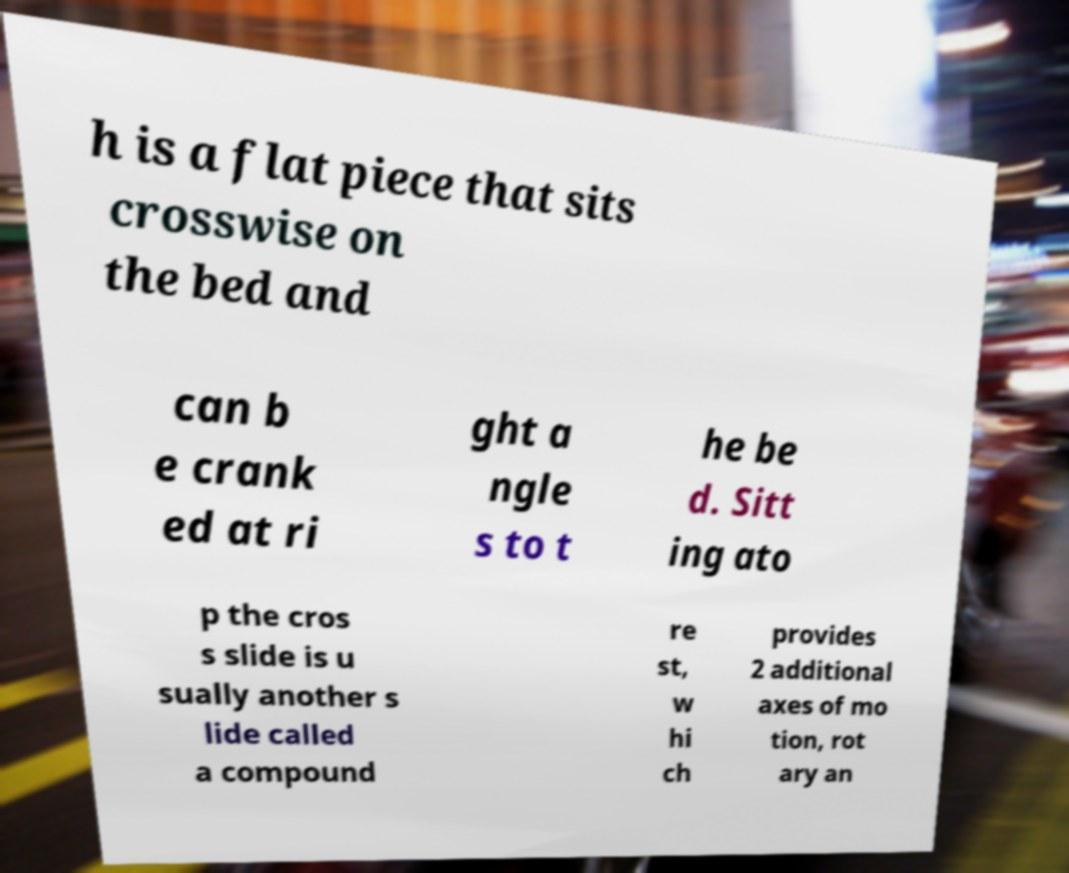Can you read and provide the text displayed in the image?This photo seems to have some interesting text. Can you extract and type it out for me? h is a flat piece that sits crosswise on the bed and can b e crank ed at ri ght a ngle s to t he be d. Sitt ing ato p the cros s slide is u sually another s lide called a compound re st, w hi ch provides 2 additional axes of mo tion, rot ary an 